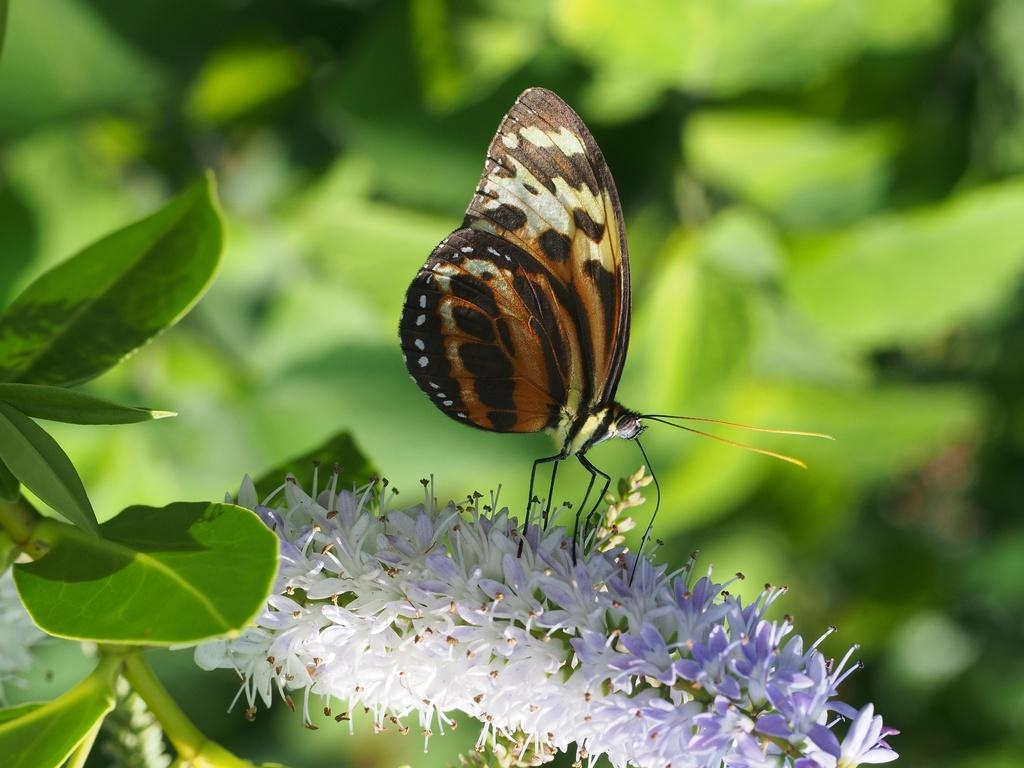What is the main subject of the image? There is a butterfly on a flower in the image. What can be seen on the left side of the image? There are leaves on the left side of the image. What is visible in the background of the image? There are plants visible in the background of the image. What type of market can be seen in the background of the image? There is no market present in the image; it features a butterfly on a flower with leaves and plants in the background. What is the chance of finding a beetle on the flower in the image? There is no beetle present in the image, so it is impossible to determine the chance of finding one on the flower. 